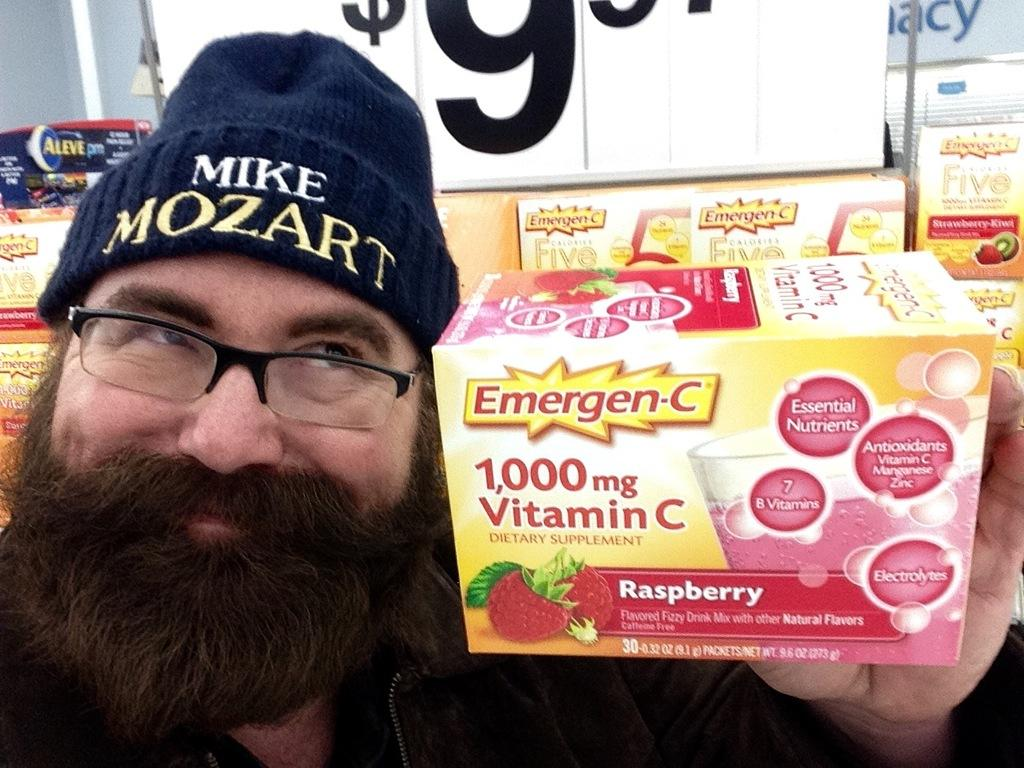Who is the main subject in the image? There is a man in the image. What is the man doing in the image? The man is showing a box. How is the man holding the box? The man is holding the box with his hand. What can be seen in the background of the image? There is a price tag and boxes in the background of the image. What type of baseball is the man playing in the image? There is no baseball or any indication of a baseball game in the image. How many planes can be seen flying in the background of the image? There are no planes visible in the image; it only shows a man holding a box and a background with a price tag and other boxes. 